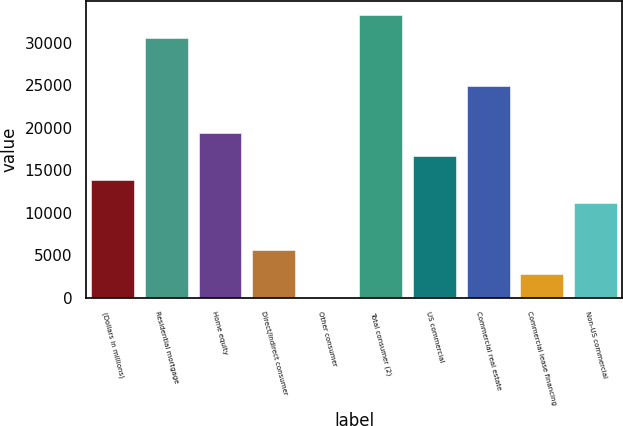Convert chart to OTSL. <chart><loc_0><loc_0><loc_500><loc_500><bar_chart><fcel>(Dollars in millions)<fcel>Residential mortgage<fcel>Home equity<fcel>Direct/Indirect consumer<fcel>Other consumer<fcel>Total consumer (2)<fcel>US commercial<fcel>Commercial real estate<fcel>Commercial lease financing<fcel>Non-US commercial<nl><fcel>13861.5<fcel>30477.3<fcel>19400.1<fcel>5553.6<fcel>15<fcel>33246.6<fcel>16630.8<fcel>24938.7<fcel>2784.3<fcel>11092.2<nl></chart> 